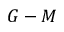<formula> <loc_0><loc_0><loc_500><loc_500>G - M</formula> 